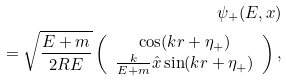Convert formula to latex. <formula><loc_0><loc_0><loc_500><loc_500>\psi _ { + } ( E , x ) \\ = \sqrt { \frac { E + m } { 2 R E } } \left ( \begin{array} { c } \cos ( k r + \eta _ { + } ) \\ \frac { k } { E + m } \hat { x } \sin ( k r + \eta _ { + } ) \end{array} \right ) ,</formula> 